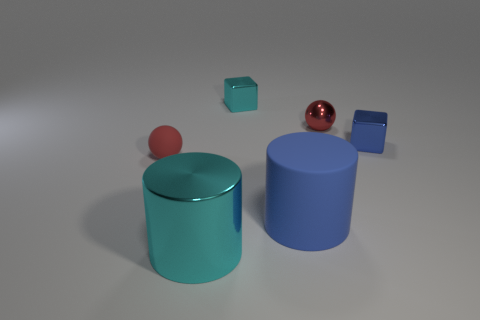There is a shiny block right of the big blue thing; is its color the same as the rubber sphere? No, the colors are not the same. The shiny block to the right of the large blue cylinder has a teal color, whereas the rubber sphere on top of the blue cylinder has a red hue. Both objects display distinct colors that are easily discernible, with the block exhibiting a cooler tone compared to the sphere's warm red. 